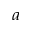Convert formula to latex. <formula><loc_0><loc_0><loc_500><loc_500>^ { a }</formula> 